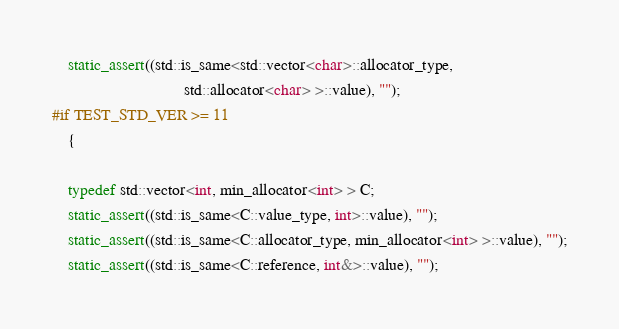<code> <loc_0><loc_0><loc_500><loc_500><_C++_>    static_assert((std::is_same<std::vector<char>::allocator_type,
                                std::allocator<char> >::value), "");
#if TEST_STD_VER >= 11
    {

    typedef std::vector<int, min_allocator<int> > C;
    static_assert((std::is_same<C::value_type, int>::value), "");
    static_assert((std::is_same<C::allocator_type, min_allocator<int> >::value), "");
    static_assert((std::is_same<C::reference, int&>::value), "");</code> 